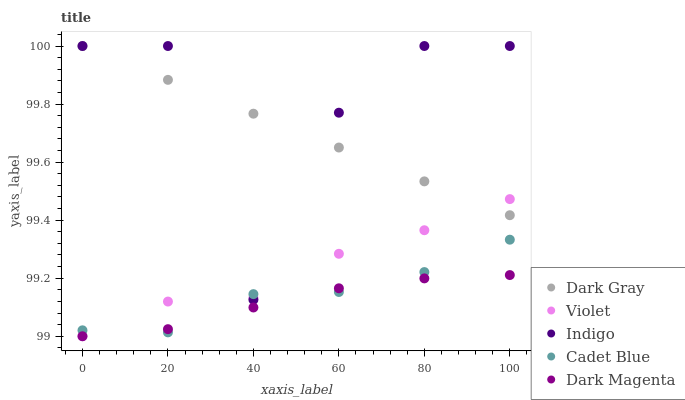Does Dark Magenta have the minimum area under the curve?
Answer yes or no. Yes. Does Indigo have the maximum area under the curve?
Answer yes or no. Yes. Does Cadet Blue have the minimum area under the curve?
Answer yes or no. No. Does Cadet Blue have the maximum area under the curve?
Answer yes or no. No. Is Dark Gray the smoothest?
Answer yes or no. Yes. Is Indigo the roughest?
Answer yes or no. Yes. Is Cadet Blue the smoothest?
Answer yes or no. No. Is Cadet Blue the roughest?
Answer yes or no. No. Does Dark Magenta have the lowest value?
Answer yes or no. Yes. Does Cadet Blue have the lowest value?
Answer yes or no. No. Does Indigo have the highest value?
Answer yes or no. Yes. Does Cadet Blue have the highest value?
Answer yes or no. No. Is Cadet Blue less than Dark Gray?
Answer yes or no. Yes. Is Indigo greater than Dark Magenta?
Answer yes or no. Yes. Does Violet intersect Cadet Blue?
Answer yes or no. Yes. Is Violet less than Cadet Blue?
Answer yes or no. No. Is Violet greater than Cadet Blue?
Answer yes or no. No. Does Cadet Blue intersect Dark Gray?
Answer yes or no. No. 